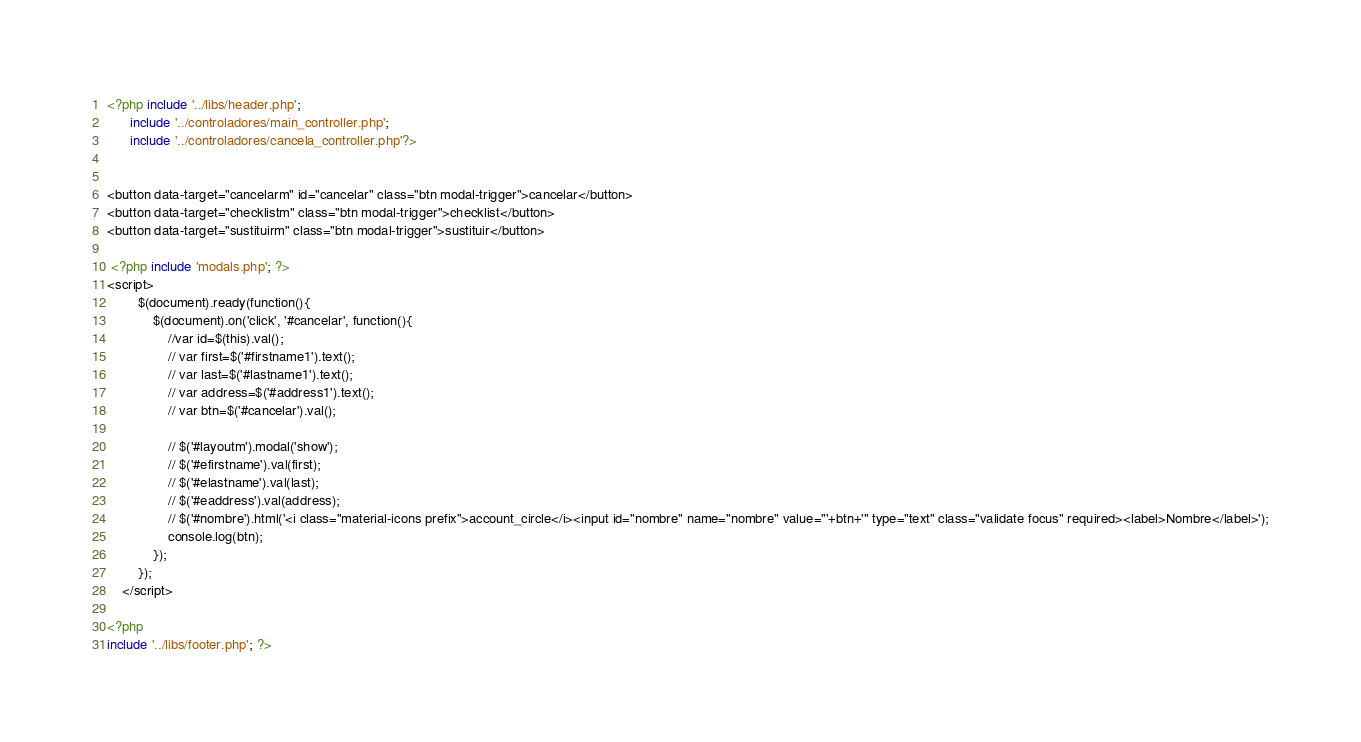Convert code to text. <code><loc_0><loc_0><loc_500><loc_500><_PHP_><?php include '../libs/header.php'; 
	  include '../controladores/main_controller.php';
	  include '../controladores/cancela_controller.php'?>


<button data-target="cancelarm" id="cancelar" class="btn modal-trigger">cancelar</button>
<button data-target="checklistm" class="btn modal-trigger">checklist</button>
<button data-target="sustituirm" class="btn modal-trigger">sustituir</button>

 <?php include 'modals.php'; ?>
<script>
		$(document).ready(function(){
			$(document).on('click', '#cancelar', function(){
				//var id=$(this).val();
				// var first=$('#firstname1').text();
				// var last=$('#lastname1').text();
				// var address=$('#address1').text();
				// var btn=$('#cancelar').val();

				// $('#layoutm').modal('show');
				// $('#efirstname').val(first);
				// $('#elastname').val(last);
				// $('#eaddress').val(address);
				// $('#nombre').html('<i class="material-icons prefix">account_circle</i><input id="nombre" name="nombre" value="'+btn+'" type="text" class="validate focus" required><label>Nombre</label>');
				console.log(btn);
			});
		});
	</script>

<?php 
include '../libs/footer.php'; ?></code> 